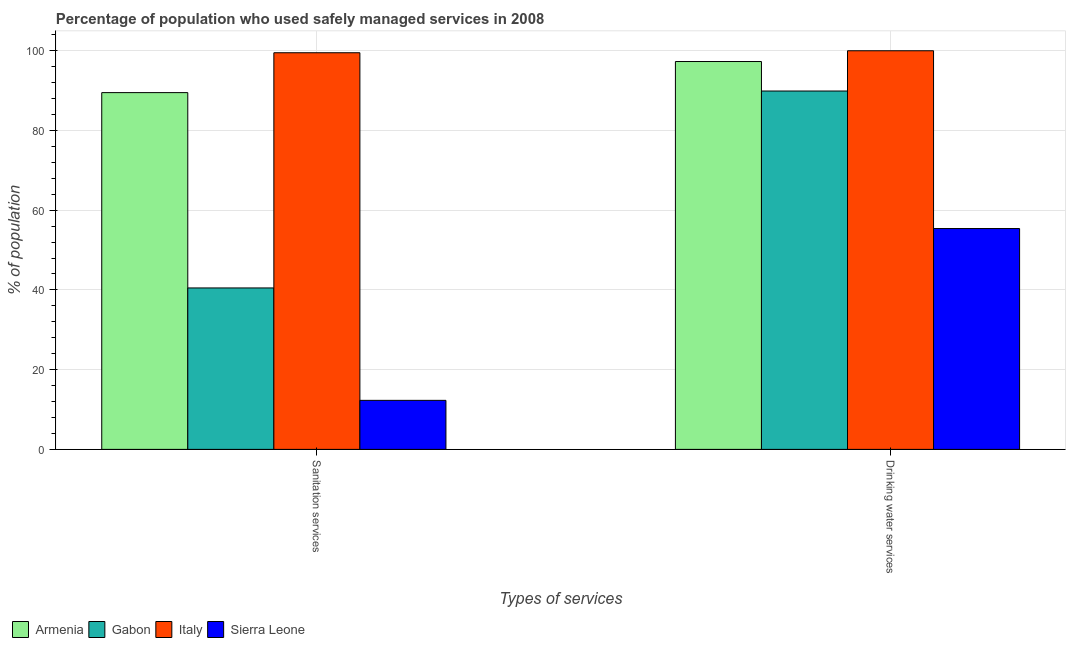How many groups of bars are there?
Offer a very short reply. 2. Are the number of bars on each tick of the X-axis equal?
Your answer should be compact. Yes. How many bars are there on the 1st tick from the right?
Your answer should be compact. 4. What is the label of the 2nd group of bars from the left?
Make the answer very short. Drinking water services. What is the percentage of population who used sanitation services in Gabon?
Provide a short and direct response. 40.5. Across all countries, what is the maximum percentage of population who used drinking water services?
Provide a short and direct response. 100. In which country was the percentage of population who used drinking water services maximum?
Make the answer very short. Italy. In which country was the percentage of population who used drinking water services minimum?
Give a very brief answer. Sierra Leone. What is the total percentage of population who used drinking water services in the graph?
Offer a very short reply. 342.6. What is the difference between the percentage of population who used sanitation services in Gabon and the percentage of population who used drinking water services in Italy?
Provide a succinct answer. -59.5. What is the average percentage of population who used sanitation services per country?
Keep it short and to the point. 60.45. What is the difference between the percentage of population who used sanitation services and percentage of population who used drinking water services in Armenia?
Your answer should be compact. -7.8. What is the ratio of the percentage of population who used drinking water services in Italy to that in Armenia?
Make the answer very short. 1.03. In how many countries, is the percentage of population who used drinking water services greater than the average percentage of population who used drinking water services taken over all countries?
Your response must be concise. 3. What does the 1st bar from the right in Drinking water services represents?
Ensure brevity in your answer.  Sierra Leone. Does the graph contain any zero values?
Your response must be concise. No. Does the graph contain grids?
Your response must be concise. Yes. How many legend labels are there?
Keep it short and to the point. 4. What is the title of the graph?
Give a very brief answer. Percentage of population who used safely managed services in 2008. What is the label or title of the X-axis?
Your answer should be compact. Types of services. What is the label or title of the Y-axis?
Your answer should be compact. % of population. What is the % of population in Armenia in Sanitation services?
Provide a short and direct response. 89.5. What is the % of population in Gabon in Sanitation services?
Give a very brief answer. 40.5. What is the % of population in Italy in Sanitation services?
Your answer should be very brief. 99.5. What is the % of population of Sierra Leone in Sanitation services?
Offer a very short reply. 12.3. What is the % of population in Armenia in Drinking water services?
Your response must be concise. 97.3. What is the % of population in Gabon in Drinking water services?
Give a very brief answer. 89.9. What is the % of population of Italy in Drinking water services?
Make the answer very short. 100. What is the % of population of Sierra Leone in Drinking water services?
Your answer should be very brief. 55.4. Across all Types of services, what is the maximum % of population of Armenia?
Offer a very short reply. 97.3. Across all Types of services, what is the maximum % of population of Gabon?
Give a very brief answer. 89.9. Across all Types of services, what is the maximum % of population in Sierra Leone?
Offer a terse response. 55.4. Across all Types of services, what is the minimum % of population of Armenia?
Provide a short and direct response. 89.5. Across all Types of services, what is the minimum % of population of Gabon?
Ensure brevity in your answer.  40.5. Across all Types of services, what is the minimum % of population of Italy?
Make the answer very short. 99.5. Across all Types of services, what is the minimum % of population in Sierra Leone?
Your answer should be compact. 12.3. What is the total % of population in Armenia in the graph?
Give a very brief answer. 186.8. What is the total % of population of Gabon in the graph?
Keep it short and to the point. 130.4. What is the total % of population in Italy in the graph?
Ensure brevity in your answer.  199.5. What is the total % of population of Sierra Leone in the graph?
Ensure brevity in your answer.  67.7. What is the difference between the % of population of Armenia in Sanitation services and that in Drinking water services?
Your answer should be very brief. -7.8. What is the difference between the % of population of Gabon in Sanitation services and that in Drinking water services?
Your answer should be very brief. -49.4. What is the difference between the % of population in Italy in Sanitation services and that in Drinking water services?
Ensure brevity in your answer.  -0.5. What is the difference between the % of population in Sierra Leone in Sanitation services and that in Drinking water services?
Offer a very short reply. -43.1. What is the difference between the % of population of Armenia in Sanitation services and the % of population of Gabon in Drinking water services?
Offer a very short reply. -0.4. What is the difference between the % of population in Armenia in Sanitation services and the % of population in Italy in Drinking water services?
Your response must be concise. -10.5. What is the difference between the % of population of Armenia in Sanitation services and the % of population of Sierra Leone in Drinking water services?
Make the answer very short. 34.1. What is the difference between the % of population in Gabon in Sanitation services and the % of population in Italy in Drinking water services?
Make the answer very short. -59.5. What is the difference between the % of population in Gabon in Sanitation services and the % of population in Sierra Leone in Drinking water services?
Offer a terse response. -14.9. What is the difference between the % of population of Italy in Sanitation services and the % of population of Sierra Leone in Drinking water services?
Offer a terse response. 44.1. What is the average % of population of Armenia per Types of services?
Your answer should be very brief. 93.4. What is the average % of population of Gabon per Types of services?
Provide a succinct answer. 65.2. What is the average % of population of Italy per Types of services?
Provide a succinct answer. 99.75. What is the average % of population in Sierra Leone per Types of services?
Keep it short and to the point. 33.85. What is the difference between the % of population in Armenia and % of population in Gabon in Sanitation services?
Offer a terse response. 49. What is the difference between the % of population in Armenia and % of population in Sierra Leone in Sanitation services?
Keep it short and to the point. 77.2. What is the difference between the % of population of Gabon and % of population of Italy in Sanitation services?
Your answer should be very brief. -59. What is the difference between the % of population in Gabon and % of population in Sierra Leone in Sanitation services?
Make the answer very short. 28.2. What is the difference between the % of population of Italy and % of population of Sierra Leone in Sanitation services?
Offer a very short reply. 87.2. What is the difference between the % of population in Armenia and % of population in Italy in Drinking water services?
Offer a very short reply. -2.7. What is the difference between the % of population of Armenia and % of population of Sierra Leone in Drinking water services?
Make the answer very short. 41.9. What is the difference between the % of population in Gabon and % of population in Sierra Leone in Drinking water services?
Your answer should be very brief. 34.5. What is the difference between the % of population of Italy and % of population of Sierra Leone in Drinking water services?
Provide a short and direct response. 44.6. What is the ratio of the % of population in Armenia in Sanitation services to that in Drinking water services?
Give a very brief answer. 0.92. What is the ratio of the % of population in Gabon in Sanitation services to that in Drinking water services?
Make the answer very short. 0.45. What is the ratio of the % of population of Italy in Sanitation services to that in Drinking water services?
Offer a very short reply. 0.99. What is the ratio of the % of population of Sierra Leone in Sanitation services to that in Drinking water services?
Offer a very short reply. 0.22. What is the difference between the highest and the second highest % of population in Armenia?
Your answer should be very brief. 7.8. What is the difference between the highest and the second highest % of population of Gabon?
Your answer should be compact. 49.4. What is the difference between the highest and the second highest % of population in Italy?
Offer a terse response. 0.5. What is the difference between the highest and the second highest % of population in Sierra Leone?
Keep it short and to the point. 43.1. What is the difference between the highest and the lowest % of population of Armenia?
Give a very brief answer. 7.8. What is the difference between the highest and the lowest % of population in Gabon?
Provide a succinct answer. 49.4. What is the difference between the highest and the lowest % of population of Italy?
Offer a very short reply. 0.5. What is the difference between the highest and the lowest % of population in Sierra Leone?
Offer a very short reply. 43.1. 